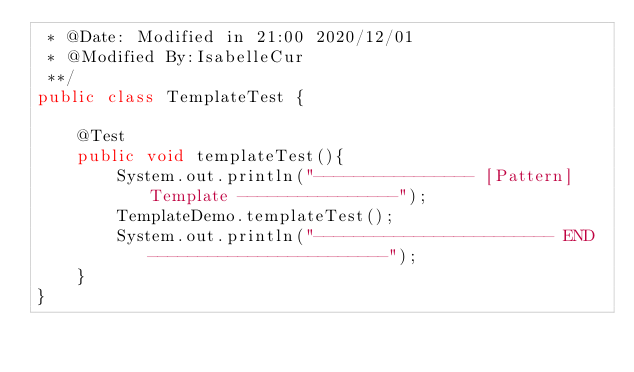Convert code to text. <code><loc_0><loc_0><loc_500><loc_500><_Java_> * @Date: Modified in 21:00 2020/12/01
 * @Modified By:IsabelleCur
 **/
public class TemplateTest {

    @Test
    public void templateTest(){
        System.out.println("---------------- [Pattern] Template ----------------");
        TemplateDemo.templateTest();
        System.out.println("------------------------ END ------------------------");
    }
}
</code> 